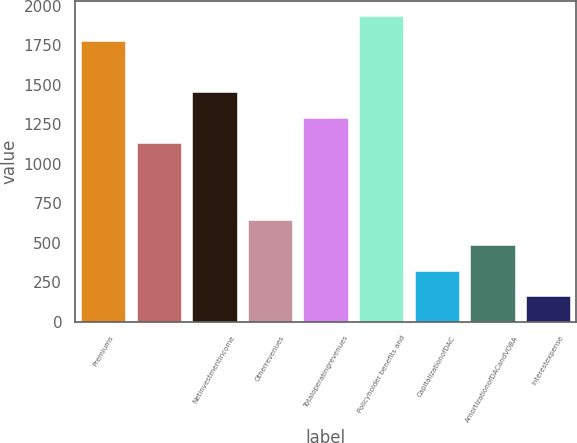<chart> <loc_0><loc_0><loc_500><loc_500><bar_chart><fcel>Premiums<fcel>Unnamed: 1<fcel>Netinvestmentincome<fcel>Otherrevenues<fcel>Totaloperatingrevenues<fcel>Policyholder benefits and<fcel>CapitalizationofDAC<fcel>AmortizationofDACandVOBA<fcel>Interestexpense<nl><fcel>1773.1<fcel>1128.7<fcel>1450.9<fcel>645.4<fcel>1289.8<fcel>1934.2<fcel>323.2<fcel>484.3<fcel>162.1<nl></chart> 